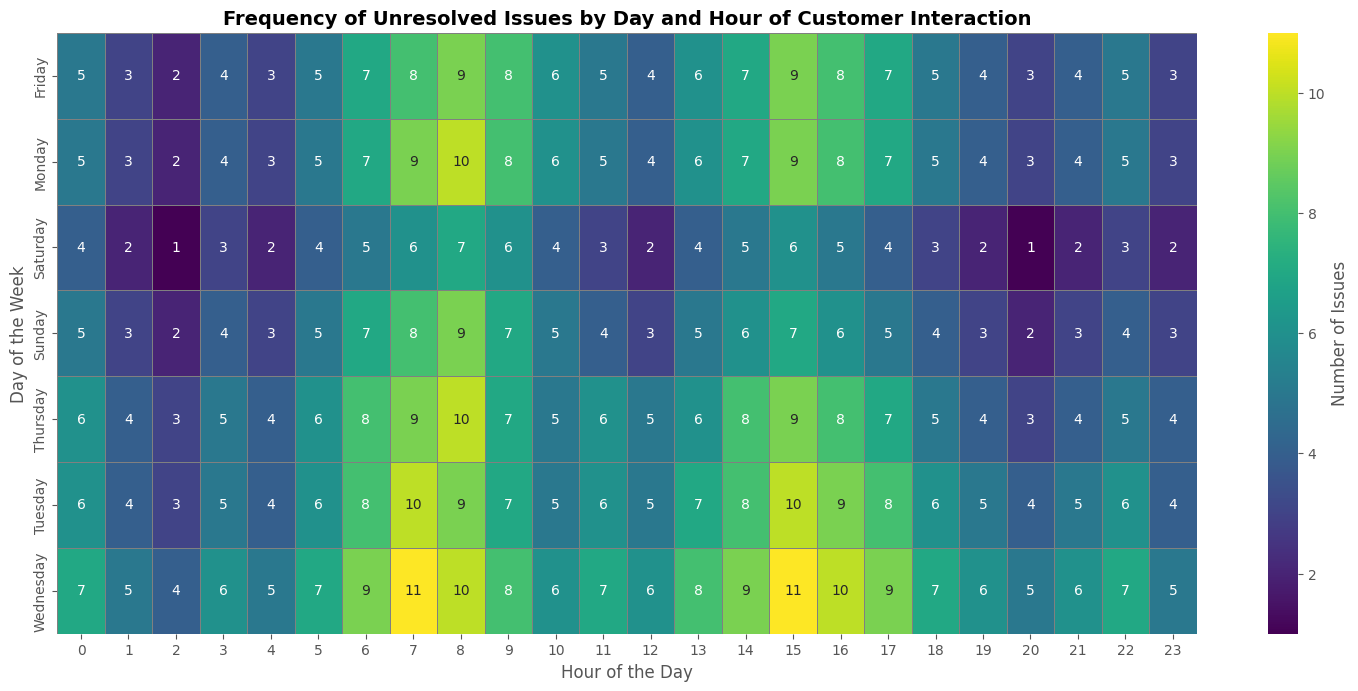Which day has the highest number of unresolved issues at 15:00? Look at the column for 15:00 and compare the numbers for each day. Identify the highest number.
Answer: Wednesday Which hour on Monday has the highest number of unresolved issues? Look at the row for Monday and compare the numbers for each hour. Identify the highest number.
Answer: 8:00 What is the total number of unresolved issues on Tuesday and Thursday combined at 08:00? Look at the columns for 08:00 and add the values for Tuesday and Thursday: 9 + 10.
Answer: 19 Is there any day where the number of unresolved issues never drops below 4 at any hour? Look at all rows and find if there is any day where all values are 4 or higher.
Answer: No On which day and hour is the peak number of unresolved issues observed? Find the cell with the highest number in the entire heatmap and note its corresponding day and hour.
Answer: Wednesday at 07:00 Compare the frequency of unresolved issues at 09:00 between Monday and Friday. Which day has more issues and by how much? Look at the column for 09:00 and compare the values for Monday and Friday. Subtract the lower value from the higher value.
Answer: Monday by 1 What is the average number of unresolved issues at 12:00 across all days? Sum the values for 12:00 across all days and divide by 7. ((4+5+6+5+4+2+3)= 29, 29/7 ≈ 4.14.
Answer: ~4.14 What pattern do you observe in the number of unresolved issues during the weekends (Saturday and Sunday) compared to weekdays (Monday to Friday)? Compare the general color intensity and numbers on Saturday and Sunday rows with those from Monday to Friday season.
Answer: Weekends have generally lower unresolved issues than weekdays Is there a significant drop in the number of unresolved issues at any particular hour across all days? Look for any hour (column) that shows consistently low values compared to surrounding hours.
Answer: Yes, at 02:00 What is the combined number of unresolved issues at 00:00 for the first three days of the week? Sum the values for 00:00 (Monday, Tuesday, Wednesday): 5 + 6 + 7.
Answer: 18 